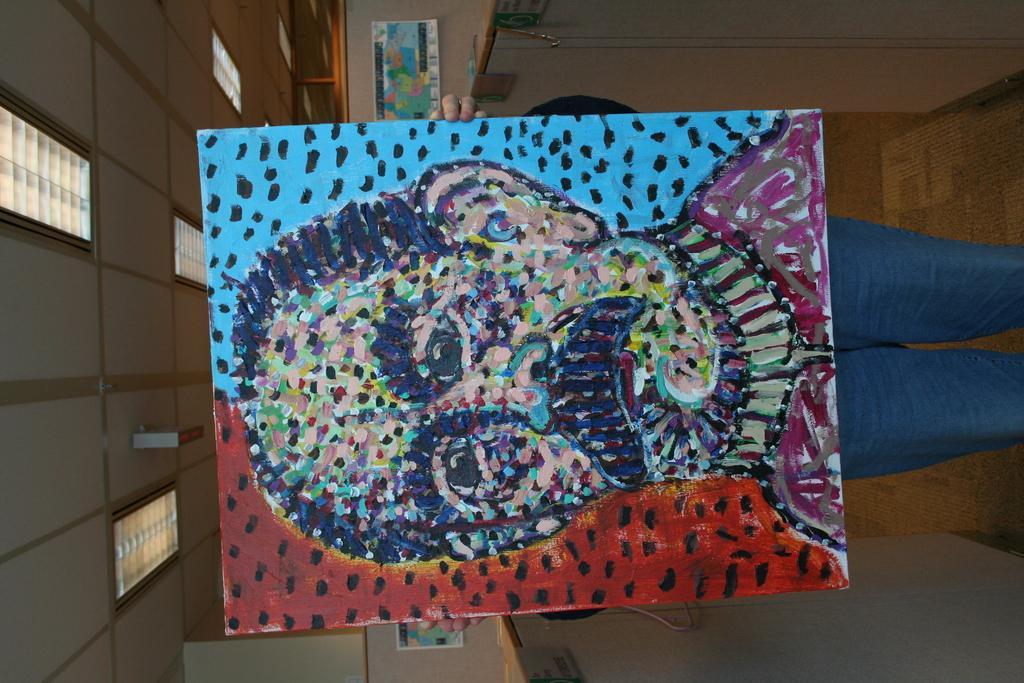Can you describe this image briefly? In this picture we can see a person is holding a painting board. Behind the person there is a wall with photo frames and at the top there are ceiling lights. On the left and right side of the person there are some objects. 